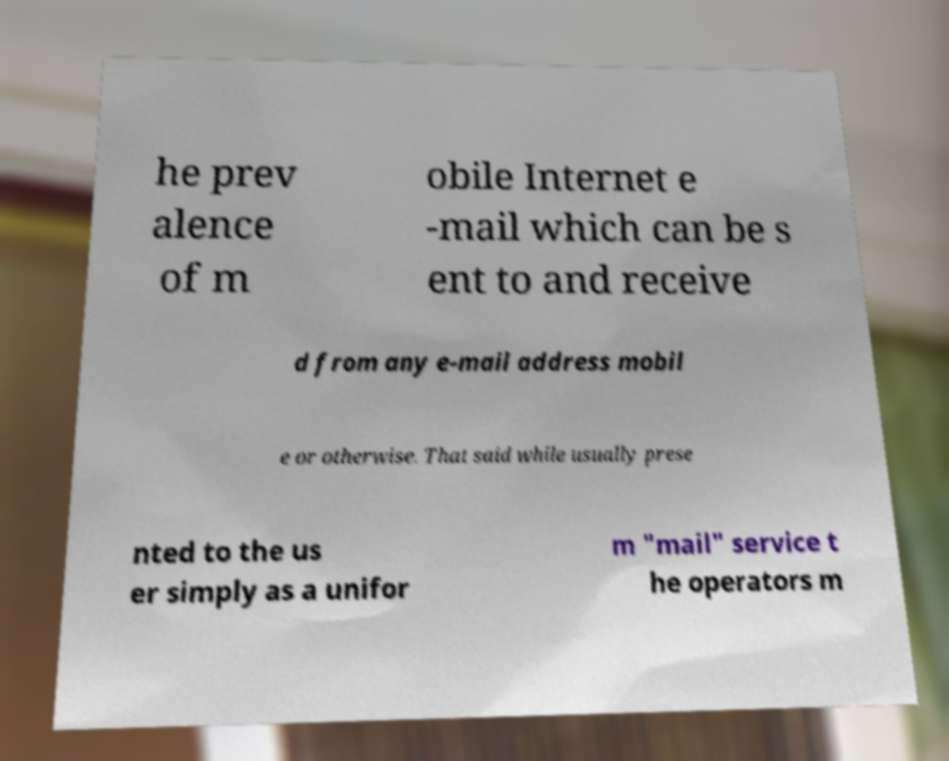Please read and relay the text visible in this image. What does it say? he prev alence of m obile Internet e -mail which can be s ent to and receive d from any e-mail address mobil e or otherwise. That said while usually prese nted to the us er simply as a unifor m "mail" service t he operators m 